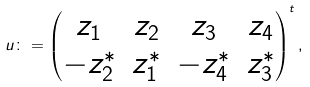Convert formula to latex. <formula><loc_0><loc_0><loc_500><loc_500>u \colon = \begin{pmatrix} z _ { 1 } & z _ { 2 } & z _ { 3 } & z _ { 4 } \\ - z _ { 2 } ^ { * } & z _ { 1 } ^ { * } & - z ^ { * } _ { 4 } & z _ { 3 } ^ { * } \end{pmatrix} ^ { t } ,</formula> 